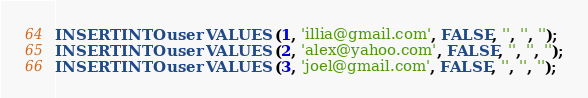<code> <loc_0><loc_0><loc_500><loc_500><_SQL_>INSERT INTO user VALUES (1, 'illia@gmail.com', FALSE, '', '', '');
INSERT INTO user VALUES (2, 'alex@yahoo.com', FALSE, '', '', '');
INSERT INTO user VALUES (3, 'joel@gmail.com', FALSE, '', '', '');</code> 